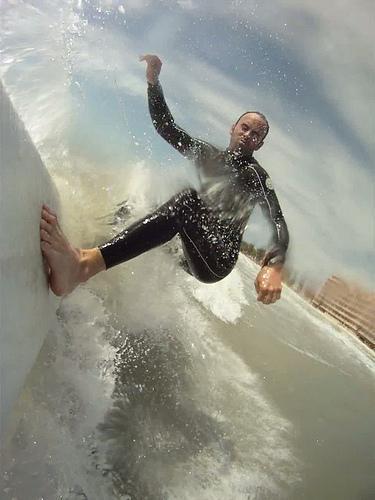How many pairs of scissors are there?
Give a very brief answer. 0. 